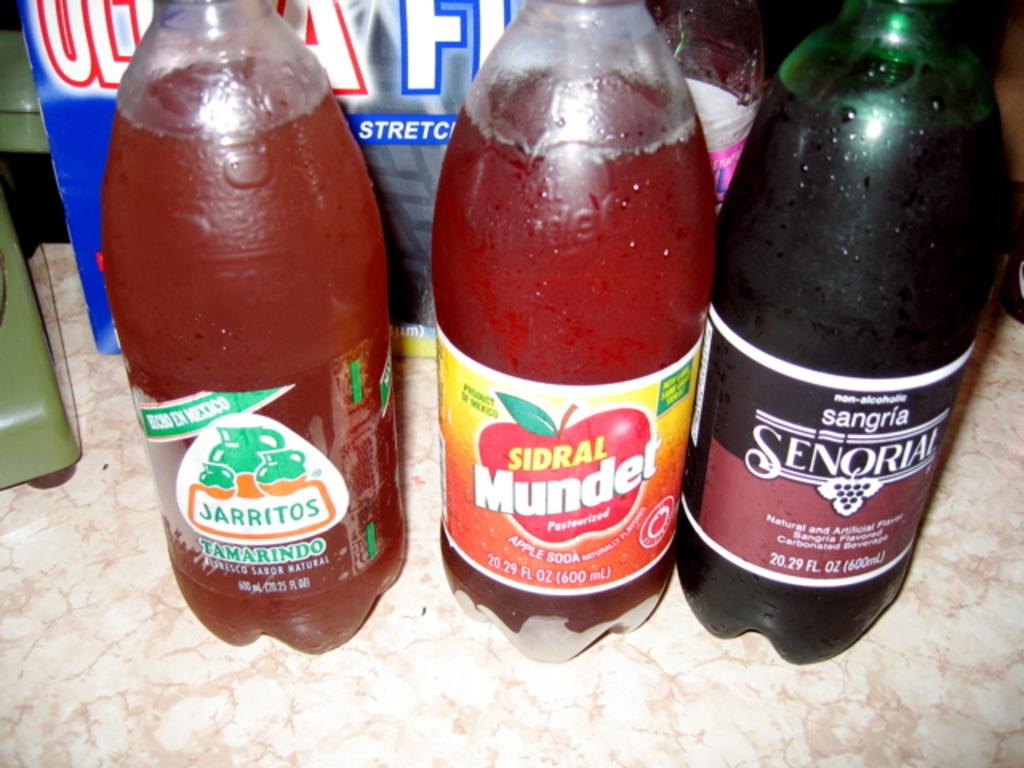<image>
Summarize the visual content of the image. Several beverage bottles sit on a surface, including a Jarritos tamarind soda. 